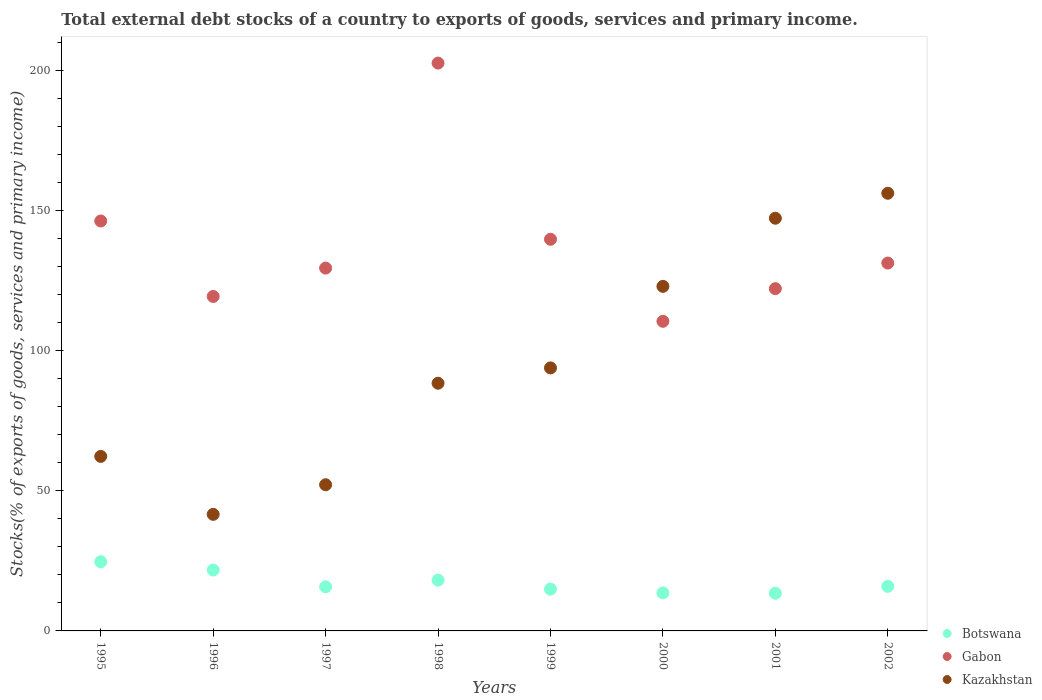How many different coloured dotlines are there?
Your response must be concise. 3. What is the total debt stocks in Kazakhstan in 2000?
Your answer should be very brief. 123. Across all years, what is the maximum total debt stocks in Gabon?
Keep it short and to the point. 202.7. Across all years, what is the minimum total debt stocks in Gabon?
Your response must be concise. 110.52. In which year was the total debt stocks in Gabon maximum?
Your response must be concise. 1998. What is the total total debt stocks in Botswana in the graph?
Provide a succinct answer. 138.16. What is the difference between the total debt stocks in Gabon in 1996 and that in 1997?
Your response must be concise. -10.12. What is the difference between the total debt stocks in Botswana in 2002 and the total debt stocks in Kazakhstan in 1999?
Your answer should be compact. -77.96. What is the average total debt stocks in Botswana per year?
Give a very brief answer. 17.27. In the year 2002, what is the difference between the total debt stocks in Botswana and total debt stocks in Kazakhstan?
Ensure brevity in your answer.  -140.3. In how many years, is the total debt stocks in Kazakhstan greater than 40 %?
Offer a very short reply. 8. What is the ratio of the total debt stocks in Botswana in 1997 to that in 2000?
Provide a succinct answer. 1.16. Is the difference between the total debt stocks in Botswana in 1996 and 2001 greater than the difference between the total debt stocks in Kazakhstan in 1996 and 2001?
Provide a succinct answer. Yes. What is the difference between the highest and the second highest total debt stocks in Gabon?
Provide a short and direct response. 56.36. What is the difference between the highest and the lowest total debt stocks in Botswana?
Give a very brief answer. 11.25. In how many years, is the total debt stocks in Kazakhstan greater than the average total debt stocks in Kazakhstan taken over all years?
Make the answer very short. 3. Is the sum of the total debt stocks in Botswana in 1997 and 2001 greater than the maximum total debt stocks in Kazakhstan across all years?
Keep it short and to the point. No. Is the total debt stocks in Gabon strictly greater than the total debt stocks in Kazakhstan over the years?
Your response must be concise. No. How many dotlines are there?
Keep it short and to the point. 3. How many years are there in the graph?
Your answer should be very brief. 8. Are the values on the major ticks of Y-axis written in scientific E-notation?
Ensure brevity in your answer.  No. How many legend labels are there?
Your response must be concise. 3. How are the legend labels stacked?
Offer a very short reply. Vertical. What is the title of the graph?
Ensure brevity in your answer.  Total external debt stocks of a country to exports of goods, services and primary income. What is the label or title of the Y-axis?
Ensure brevity in your answer.  Stocks(% of exports of goods, services and primary income). What is the Stocks(% of exports of goods, services and primary income) of Botswana in 1995?
Provide a succinct answer. 24.7. What is the Stocks(% of exports of goods, services and primary income) of Gabon in 1995?
Ensure brevity in your answer.  146.34. What is the Stocks(% of exports of goods, services and primary income) in Kazakhstan in 1995?
Give a very brief answer. 62.3. What is the Stocks(% of exports of goods, services and primary income) in Botswana in 1996?
Provide a succinct answer. 21.74. What is the Stocks(% of exports of goods, services and primary income) of Gabon in 1996?
Provide a succinct answer. 119.4. What is the Stocks(% of exports of goods, services and primary income) of Kazakhstan in 1996?
Your answer should be very brief. 41.61. What is the Stocks(% of exports of goods, services and primary income) of Botswana in 1997?
Give a very brief answer. 15.74. What is the Stocks(% of exports of goods, services and primary income) in Gabon in 1997?
Provide a succinct answer. 129.52. What is the Stocks(% of exports of goods, services and primary income) of Kazakhstan in 1997?
Your response must be concise. 52.18. What is the Stocks(% of exports of goods, services and primary income) in Botswana in 1998?
Provide a short and direct response. 18.11. What is the Stocks(% of exports of goods, services and primary income) of Gabon in 1998?
Offer a very short reply. 202.7. What is the Stocks(% of exports of goods, services and primary income) in Kazakhstan in 1998?
Make the answer very short. 88.42. What is the Stocks(% of exports of goods, services and primary income) in Botswana in 1999?
Keep it short and to the point. 14.92. What is the Stocks(% of exports of goods, services and primary income) in Gabon in 1999?
Provide a succinct answer. 139.81. What is the Stocks(% of exports of goods, services and primary income) in Kazakhstan in 1999?
Your answer should be very brief. 93.89. What is the Stocks(% of exports of goods, services and primary income) of Botswana in 2000?
Your response must be concise. 13.57. What is the Stocks(% of exports of goods, services and primary income) in Gabon in 2000?
Make the answer very short. 110.52. What is the Stocks(% of exports of goods, services and primary income) of Kazakhstan in 2000?
Your response must be concise. 123. What is the Stocks(% of exports of goods, services and primary income) of Botswana in 2001?
Your response must be concise. 13.45. What is the Stocks(% of exports of goods, services and primary income) of Gabon in 2001?
Keep it short and to the point. 122.18. What is the Stocks(% of exports of goods, services and primary income) of Kazakhstan in 2001?
Your answer should be very brief. 147.32. What is the Stocks(% of exports of goods, services and primary income) in Botswana in 2002?
Your answer should be very brief. 15.93. What is the Stocks(% of exports of goods, services and primary income) in Gabon in 2002?
Provide a short and direct response. 131.31. What is the Stocks(% of exports of goods, services and primary income) in Kazakhstan in 2002?
Keep it short and to the point. 156.23. Across all years, what is the maximum Stocks(% of exports of goods, services and primary income) of Botswana?
Provide a succinct answer. 24.7. Across all years, what is the maximum Stocks(% of exports of goods, services and primary income) in Gabon?
Make the answer very short. 202.7. Across all years, what is the maximum Stocks(% of exports of goods, services and primary income) in Kazakhstan?
Your answer should be compact. 156.23. Across all years, what is the minimum Stocks(% of exports of goods, services and primary income) in Botswana?
Keep it short and to the point. 13.45. Across all years, what is the minimum Stocks(% of exports of goods, services and primary income) of Gabon?
Ensure brevity in your answer.  110.52. Across all years, what is the minimum Stocks(% of exports of goods, services and primary income) in Kazakhstan?
Your answer should be very brief. 41.61. What is the total Stocks(% of exports of goods, services and primary income) of Botswana in the graph?
Provide a short and direct response. 138.16. What is the total Stocks(% of exports of goods, services and primary income) in Gabon in the graph?
Provide a succinct answer. 1101.78. What is the total Stocks(% of exports of goods, services and primary income) of Kazakhstan in the graph?
Make the answer very short. 764.96. What is the difference between the Stocks(% of exports of goods, services and primary income) in Botswana in 1995 and that in 1996?
Offer a terse response. 2.96. What is the difference between the Stocks(% of exports of goods, services and primary income) in Gabon in 1995 and that in 1996?
Give a very brief answer. 26.94. What is the difference between the Stocks(% of exports of goods, services and primary income) in Kazakhstan in 1995 and that in 1996?
Keep it short and to the point. 20.69. What is the difference between the Stocks(% of exports of goods, services and primary income) of Botswana in 1995 and that in 1997?
Your answer should be very brief. 8.96. What is the difference between the Stocks(% of exports of goods, services and primary income) of Gabon in 1995 and that in 1997?
Provide a short and direct response. 16.82. What is the difference between the Stocks(% of exports of goods, services and primary income) in Kazakhstan in 1995 and that in 1997?
Your response must be concise. 10.12. What is the difference between the Stocks(% of exports of goods, services and primary income) in Botswana in 1995 and that in 1998?
Make the answer very short. 6.59. What is the difference between the Stocks(% of exports of goods, services and primary income) of Gabon in 1995 and that in 1998?
Provide a short and direct response. -56.36. What is the difference between the Stocks(% of exports of goods, services and primary income) in Kazakhstan in 1995 and that in 1998?
Your answer should be compact. -26.12. What is the difference between the Stocks(% of exports of goods, services and primary income) of Botswana in 1995 and that in 1999?
Your answer should be compact. 9.78. What is the difference between the Stocks(% of exports of goods, services and primary income) in Gabon in 1995 and that in 1999?
Provide a short and direct response. 6.53. What is the difference between the Stocks(% of exports of goods, services and primary income) of Kazakhstan in 1995 and that in 1999?
Offer a terse response. -31.59. What is the difference between the Stocks(% of exports of goods, services and primary income) of Botswana in 1995 and that in 2000?
Your answer should be compact. 11.13. What is the difference between the Stocks(% of exports of goods, services and primary income) of Gabon in 1995 and that in 2000?
Keep it short and to the point. 35.81. What is the difference between the Stocks(% of exports of goods, services and primary income) in Kazakhstan in 1995 and that in 2000?
Your answer should be very brief. -60.7. What is the difference between the Stocks(% of exports of goods, services and primary income) of Botswana in 1995 and that in 2001?
Provide a short and direct response. 11.25. What is the difference between the Stocks(% of exports of goods, services and primary income) in Gabon in 1995 and that in 2001?
Give a very brief answer. 24.16. What is the difference between the Stocks(% of exports of goods, services and primary income) of Kazakhstan in 1995 and that in 2001?
Offer a very short reply. -85.02. What is the difference between the Stocks(% of exports of goods, services and primary income) of Botswana in 1995 and that in 2002?
Provide a short and direct response. 8.77. What is the difference between the Stocks(% of exports of goods, services and primary income) in Gabon in 1995 and that in 2002?
Provide a succinct answer. 15.02. What is the difference between the Stocks(% of exports of goods, services and primary income) of Kazakhstan in 1995 and that in 2002?
Keep it short and to the point. -93.93. What is the difference between the Stocks(% of exports of goods, services and primary income) in Botswana in 1996 and that in 1997?
Provide a succinct answer. 6. What is the difference between the Stocks(% of exports of goods, services and primary income) in Gabon in 1996 and that in 1997?
Provide a succinct answer. -10.12. What is the difference between the Stocks(% of exports of goods, services and primary income) in Kazakhstan in 1996 and that in 1997?
Your response must be concise. -10.57. What is the difference between the Stocks(% of exports of goods, services and primary income) in Botswana in 1996 and that in 1998?
Give a very brief answer. 3.63. What is the difference between the Stocks(% of exports of goods, services and primary income) of Gabon in 1996 and that in 1998?
Your answer should be very brief. -83.3. What is the difference between the Stocks(% of exports of goods, services and primary income) of Kazakhstan in 1996 and that in 1998?
Make the answer very short. -46.81. What is the difference between the Stocks(% of exports of goods, services and primary income) of Botswana in 1996 and that in 1999?
Offer a terse response. 6.82. What is the difference between the Stocks(% of exports of goods, services and primary income) of Gabon in 1996 and that in 1999?
Your answer should be compact. -20.41. What is the difference between the Stocks(% of exports of goods, services and primary income) of Kazakhstan in 1996 and that in 1999?
Your response must be concise. -52.28. What is the difference between the Stocks(% of exports of goods, services and primary income) in Botswana in 1996 and that in 2000?
Ensure brevity in your answer.  8.17. What is the difference between the Stocks(% of exports of goods, services and primary income) of Gabon in 1996 and that in 2000?
Offer a terse response. 8.88. What is the difference between the Stocks(% of exports of goods, services and primary income) in Kazakhstan in 1996 and that in 2000?
Give a very brief answer. -81.39. What is the difference between the Stocks(% of exports of goods, services and primary income) of Botswana in 1996 and that in 2001?
Give a very brief answer. 8.29. What is the difference between the Stocks(% of exports of goods, services and primary income) in Gabon in 1996 and that in 2001?
Give a very brief answer. -2.78. What is the difference between the Stocks(% of exports of goods, services and primary income) in Kazakhstan in 1996 and that in 2001?
Give a very brief answer. -105.71. What is the difference between the Stocks(% of exports of goods, services and primary income) in Botswana in 1996 and that in 2002?
Provide a succinct answer. 5.81. What is the difference between the Stocks(% of exports of goods, services and primary income) of Gabon in 1996 and that in 2002?
Ensure brevity in your answer.  -11.92. What is the difference between the Stocks(% of exports of goods, services and primary income) in Kazakhstan in 1996 and that in 2002?
Provide a succinct answer. -114.62. What is the difference between the Stocks(% of exports of goods, services and primary income) of Botswana in 1997 and that in 1998?
Your answer should be compact. -2.38. What is the difference between the Stocks(% of exports of goods, services and primary income) in Gabon in 1997 and that in 1998?
Provide a succinct answer. -73.18. What is the difference between the Stocks(% of exports of goods, services and primary income) of Kazakhstan in 1997 and that in 1998?
Your response must be concise. -36.24. What is the difference between the Stocks(% of exports of goods, services and primary income) in Botswana in 1997 and that in 1999?
Provide a succinct answer. 0.82. What is the difference between the Stocks(% of exports of goods, services and primary income) of Gabon in 1997 and that in 1999?
Make the answer very short. -10.29. What is the difference between the Stocks(% of exports of goods, services and primary income) in Kazakhstan in 1997 and that in 1999?
Give a very brief answer. -41.71. What is the difference between the Stocks(% of exports of goods, services and primary income) in Botswana in 1997 and that in 2000?
Give a very brief answer. 2.17. What is the difference between the Stocks(% of exports of goods, services and primary income) in Gabon in 1997 and that in 2000?
Your response must be concise. 19. What is the difference between the Stocks(% of exports of goods, services and primary income) in Kazakhstan in 1997 and that in 2000?
Your answer should be compact. -70.82. What is the difference between the Stocks(% of exports of goods, services and primary income) of Botswana in 1997 and that in 2001?
Provide a succinct answer. 2.29. What is the difference between the Stocks(% of exports of goods, services and primary income) in Gabon in 1997 and that in 2001?
Provide a succinct answer. 7.34. What is the difference between the Stocks(% of exports of goods, services and primary income) in Kazakhstan in 1997 and that in 2001?
Provide a succinct answer. -95.14. What is the difference between the Stocks(% of exports of goods, services and primary income) in Botswana in 1997 and that in 2002?
Offer a terse response. -0.19. What is the difference between the Stocks(% of exports of goods, services and primary income) in Gabon in 1997 and that in 2002?
Your answer should be compact. -1.79. What is the difference between the Stocks(% of exports of goods, services and primary income) of Kazakhstan in 1997 and that in 2002?
Give a very brief answer. -104.05. What is the difference between the Stocks(% of exports of goods, services and primary income) of Botswana in 1998 and that in 1999?
Your answer should be very brief. 3.19. What is the difference between the Stocks(% of exports of goods, services and primary income) in Gabon in 1998 and that in 1999?
Provide a short and direct response. 62.89. What is the difference between the Stocks(% of exports of goods, services and primary income) of Kazakhstan in 1998 and that in 1999?
Your answer should be compact. -5.47. What is the difference between the Stocks(% of exports of goods, services and primary income) in Botswana in 1998 and that in 2000?
Keep it short and to the point. 4.54. What is the difference between the Stocks(% of exports of goods, services and primary income) of Gabon in 1998 and that in 2000?
Keep it short and to the point. 92.18. What is the difference between the Stocks(% of exports of goods, services and primary income) in Kazakhstan in 1998 and that in 2000?
Ensure brevity in your answer.  -34.58. What is the difference between the Stocks(% of exports of goods, services and primary income) of Botswana in 1998 and that in 2001?
Make the answer very short. 4.66. What is the difference between the Stocks(% of exports of goods, services and primary income) in Gabon in 1998 and that in 2001?
Provide a short and direct response. 80.53. What is the difference between the Stocks(% of exports of goods, services and primary income) of Kazakhstan in 1998 and that in 2001?
Ensure brevity in your answer.  -58.9. What is the difference between the Stocks(% of exports of goods, services and primary income) of Botswana in 1998 and that in 2002?
Provide a succinct answer. 2.18. What is the difference between the Stocks(% of exports of goods, services and primary income) of Gabon in 1998 and that in 2002?
Make the answer very short. 71.39. What is the difference between the Stocks(% of exports of goods, services and primary income) in Kazakhstan in 1998 and that in 2002?
Make the answer very short. -67.81. What is the difference between the Stocks(% of exports of goods, services and primary income) of Botswana in 1999 and that in 2000?
Offer a terse response. 1.35. What is the difference between the Stocks(% of exports of goods, services and primary income) of Gabon in 1999 and that in 2000?
Keep it short and to the point. 29.28. What is the difference between the Stocks(% of exports of goods, services and primary income) of Kazakhstan in 1999 and that in 2000?
Keep it short and to the point. -29.11. What is the difference between the Stocks(% of exports of goods, services and primary income) of Botswana in 1999 and that in 2001?
Provide a succinct answer. 1.47. What is the difference between the Stocks(% of exports of goods, services and primary income) in Gabon in 1999 and that in 2001?
Provide a short and direct response. 17.63. What is the difference between the Stocks(% of exports of goods, services and primary income) in Kazakhstan in 1999 and that in 2001?
Ensure brevity in your answer.  -53.43. What is the difference between the Stocks(% of exports of goods, services and primary income) in Botswana in 1999 and that in 2002?
Offer a terse response. -1.01. What is the difference between the Stocks(% of exports of goods, services and primary income) in Gabon in 1999 and that in 2002?
Your answer should be very brief. 8.49. What is the difference between the Stocks(% of exports of goods, services and primary income) of Kazakhstan in 1999 and that in 2002?
Offer a terse response. -62.34. What is the difference between the Stocks(% of exports of goods, services and primary income) of Botswana in 2000 and that in 2001?
Ensure brevity in your answer.  0.12. What is the difference between the Stocks(% of exports of goods, services and primary income) in Gabon in 2000 and that in 2001?
Provide a succinct answer. -11.65. What is the difference between the Stocks(% of exports of goods, services and primary income) of Kazakhstan in 2000 and that in 2001?
Offer a terse response. -24.32. What is the difference between the Stocks(% of exports of goods, services and primary income) in Botswana in 2000 and that in 2002?
Ensure brevity in your answer.  -2.36. What is the difference between the Stocks(% of exports of goods, services and primary income) in Gabon in 2000 and that in 2002?
Your response must be concise. -20.79. What is the difference between the Stocks(% of exports of goods, services and primary income) in Kazakhstan in 2000 and that in 2002?
Offer a very short reply. -33.23. What is the difference between the Stocks(% of exports of goods, services and primary income) of Botswana in 2001 and that in 2002?
Make the answer very short. -2.48. What is the difference between the Stocks(% of exports of goods, services and primary income) of Gabon in 2001 and that in 2002?
Ensure brevity in your answer.  -9.14. What is the difference between the Stocks(% of exports of goods, services and primary income) of Kazakhstan in 2001 and that in 2002?
Make the answer very short. -8.91. What is the difference between the Stocks(% of exports of goods, services and primary income) in Botswana in 1995 and the Stocks(% of exports of goods, services and primary income) in Gabon in 1996?
Offer a very short reply. -94.7. What is the difference between the Stocks(% of exports of goods, services and primary income) in Botswana in 1995 and the Stocks(% of exports of goods, services and primary income) in Kazakhstan in 1996?
Offer a terse response. -16.91. What is the difference between the Stocks(% of exports of goods, services and primary income) in Gabon in 1995 and the Stocks(% of exports of goods, services and primary income) in Kazakhstan in 1996?
Your answer should be compact. 104.73. What is the difference between the Stocks(% of exports of goods, services and primary income) in Botswana in 1995 and the Stocks(% of exports of goods, services and primary income) in Gabon in 1997?
Ensure brevity in your answer.  -104.82. What is the difference between the Stocks(% of exports of goods, services and primary income) of Botswana in 1995 and the Stocks(% of exports of goods, services and primary income) of Kazakhstan in 1997?
Provide a short and direct response. -27.48. What is the difference between the Stocks(% of exports of goods, services and primary income) of Gabon in 1995 and the Stocks(% of exports of goods, services and primary income) of Kazakhstan in 1997?
Provide a short and direct response. 94.16. What is the difference between the Stocks(% of exports of goods, services and primary income) of Botswana in 1995 and the Stocks(% of exports of goods, services and primary income) of Gabon in 1998?
Provide a succinct answer. -178. What is the difference between the Stocks(% of exports of goods, services and primary income) of Botswana in 1995 and the Stocks(% of exports of goods, services and primary income) of Kazakhstan in 1998?
Your response must be concise. -63.72. What is the difference between the Stocks(% of exports of goods, services and primary income) of Gabon in 1995 and the Stocks(% of exports of goods, services and primary income) of Kazakhstan in 1998?
Ensure brevity in your answer.  57.92. What is the difference between the Stocks(% of exports of goods, services and primary income) of Botswana in 1995 and the Stocks(% of exports of goods, services and primary income) of Gabon in 1999?
Provide a succinct answer. -115.11. What is the difference between the Stocks(% of exports of goods, services and primary income) of Botswana in 1995 and the Stocks(% of exports of goods, services and primary income) of Kazakhstan in 1999?
Your response must be concise. -69.19. What is the difference between the Stocks(% of exports of goods, services and primary income) of Gabon in 1995 and the Stocks(% of exports of goods, services and primary income) of Kazakhstan in 1999?
Provide a short and direct response. 52.45. What is the difference between the Stocks(% of exports of goods, services and primary income) of Botswana in 1995 and the Stocks(% of exports of goods, services and primary income) of Gabon in 2000?
Give a very brief answer. -85.83. What is the difference between the Stocks(% of exports of goods, services and primary income) of Botswana in 1995 and the Stocks(% of exports of goods, services and primary income) of Kazakhstan in 2000?
Ensure brevity in your answer.  -98.3. What is the difference between the Stocks(% of exports of goods, services and primary income) of Gabon in 1995 and the Stocks(% of exports of goods, services and primary income) of Kazakhstan in 2000?
Give a very brief answer. 23.34. What is the difference between the Stocks(% of exports of goods, services and primary income) of Botswana in 1995 and the Stocks(% of exports of goods, services and primary income) of Gabon in 2001?
Make the answer very short. -97.48. What is the difference between the Stocks(% of exports of goods, services and primary income) of Botswana in 1995 and the Stocks(% of exports of goods, services and primary income) of Kazakhstan in 2001?
Provide a short and direct response. -122.62. What is the difference between the Stocks(% of exports of goods, services and primary income) in Gabon in 1995 and the Stocks(% of exports of goods, services and primary income) in Kazakhstan in 2001?
Your answer should be very brief. -0.98. What is the difference between the Stocks(% of exports of goods, services and primary income) in Botswana in 1995 and the Stocks(% of exports of goods, services and primary income) in Gabon in 2002?
Offer a terse response. -106.62. What is the difference between the Stocks(% of exports of goods, services and primary income) in Botswana in 1995 and the Stocks(% of exports of goods, services and primary income) in Kazakhstan in 2002?
Ensure brevity in your answer.  -131.54. What is the difference between the Stocks(% of exports of goods, services and primary income) of Gabon in 1995 and the Stocks(% of exports of goods, services and primary income) of Kazakhstan in 2002?
Offer a terse response. -9.9. What is the difference between the Stocks(% of exports of goods, services and primary income) in Botswana in 1996 and the Stocks(% of exports of goods, services and primary income) in Gabon in 1997?
Your answer should be compact. -107.78. What is the difference between the Stocks(% of exports of goods, services and primary income) of Botswana in 1996 and the Stocks(% of exports of goods, services and primary income) of Kazakhstan in 1997?
Provide a succinct answer. -30.44. What is the difference between the Stocks(% of exports of goods, services and primary income) in Gabon in 1996 and the Stocks(% of exports of goods, services and primary income) in Kazakhstan in 1997?
Ensure brevity in your answer.  67.22. What is the difference between the Stocks(% of exports of goods, services and primary income) of Botswana in 1996 and the Stocks(% of exports of goods, services and primary income) of Gabon in 1998?
Your response must be concise. -180.96. What is the difference between the Stocks(% of exports of goods, services and primary income) of Botswana in 1996 and the Stocks(% of exports of goods, services and primary income) of Kazakhstan in 1998?
Your answer should be very brief. -66.68. What is the difference between the Stocks(% of exports of goods, services and primary income) of Gabon in 1996 and the Stocks(% of exports of goods, services and primary income) of Kazakhstan in 1998?
Your answer should be compact. 30.98. What is the difference between the Stocks(% of exports of goods, services and primary income) in Botswana in 1996 and the Stocks(% of exports of goods, services and primary income) in Gabon in 1999?
Ensure brevity in your answer.  -118.07. What is the difference between the Stocks(% of exports of goods, services and primary income) of Botswana in 1996 and the Stocks(% of exports of goods, services and primary income) of Kazakhstan in 1999?
Your answer should be very brief. -72.15. What is the difference between the Stocks(% of exports of goods, services and primary income) of Gabon in 1996 and the Stocks(% of exports of goods, services and primary income) of Kazakhstan in 1999?
Your response must be concise. 25.51. What is the difference between the Stocks(% of exports of goods, services and primary income) of Botswana in 1996 and the Stocks(% of exports of goods, services and primary income) of Gabon in 2000?
Offer a very short reply. -88.79. What is the difference between the Stocks(% of exports of goods, services and primary income) in Botswana in 1996 and the Stocks(% of exports of goods, services and primary income) in Kazakhstan in 2000?
Your answer should be compact. -101.26. What is the difference between the Stocks(% of exports of goods, services and primary income) of Gabon in 1996 and the Stocks(% of exports of goods, services and primary income) of Kazakhstan in 2000?
Offer a terse response. -3.6. What is the difference between the Stocks(% of exports of goods, services and primary income) of Botswana in 1996 and the Stocks(% of exports of goods, services and primary income) of Gabon in 2001?
Give a very brief answer. -100.44. What is the difference between the Stocks(% of exports of goods, services and primary income) of Botswana in 1996 and the Stocks(% of exports of goods, services and primary income) of Kazakhstan in 2001?
Provide a succinct answer. -125.58. What is the difference between the Stocks(% of exports of goods, services and primary income) of Gabon in 1996 and the Stocks(% of exports of goods, services and primary income) of Kazakhstan in 2001?
Offer a terse response. -27.92. What is the difference between the Stocks(% of exports of goods, services and primary income) in Botswana in 1996 and the Stocks(% of exports of goods, services and primary income) in Gabon in 2002?
Ensure brevity in your answer.  -109.58. What is the difference between the Stocks(% of exports of goods, services and primary income) in Botswana in 1996 and the Stocks(% of exports of goods, services and primary income) in Kazakhstan in 2002?
Ensure brevity in your answer.  -134.5. What is the difference between the Stocks(% of exports of goods, services and primary income) in Gabon in 1996 and the Stocks(% of exports of goods, services and primary income) in Kazakhstan in 2002?
Provide a short and direct response. -36.83. What is the difference between the Stocks(% of exports of goods, services and primary income) of Botswana in 1997 and the Stocks(% of exports of goods, services and primary income) of Gabon in 1998?
Your answer should be compact. -186.96. What is the difference between the Stocks(% of exports of goods, services and primary income) of Botswana in 1997 and the Stocks(% of exports of goods, services and primary income) of Kazakhstan in 1998?
Your response must be concise. -72.68. What is the difference between the Stocks(% of exports of goods, services and primary income) of Gabon in 1997 and the Stocks(% of exports of goods, services and primary income) of Kazakhstan in 1998?
Offer a terse response. 41.1. What is the difference between the Stocks(% of exports of goods, services and primary income) of Botswana in 1997 and the Stocks(% of exports of goods, services and primary income) of Gabon in 1999?
Your answer should be very brief. -124.07. What is the difference between the Stocks(% of exports of goods, services and primary income) in Botswana in 1997 and the Stocks(% of exports of goods, services and primary income) in Kazakhstan in 1999?
Ensure brevity in your answer.  -78.15. What is the difference between the Stocks(% of exports of goods, services and primary income) in Gabon in 1997 and the Stocks(% of exports of goods, services and primary income) in Kazakhstan in 1999?
Your answer should be very brief. 35.63. What is the difference between the Stocks(% of exports of goods, services and primary income) of Botswana in 1997 and the Stocks(% of exports of goods, services and primary income) of Gabon in 2000?
Give a very brief answer. -94.79. What is the difference between the Stocks(% of exports of goods, services and primary income) of Botswana in 1997 and the Stocks(% of exports of goods, services and primary income) of Kazakhstan in 2000?
Make the answer very short. -107.26. What is the difference between the Stocks(% of exports of goods, services and primary income) in Gabon in 1997 and the Stocks(% of exports of goods, services and primary income) in Kazakhstan in 2000?
Offer a terse response. 6.52. What is the difference between the Stocks(% of exports of goods, services and primary income) in Botswana in 1997 and the Stocks(% of exports of goods, services and primary income) in Gabon in 2001?
Ensure brevity in your answer.  -106.44. What is the difference between the Stocks(% of exports of goods, services and primary income) in Botswana in 1997 and the Stocks(% of exports of goods, services and primary income) in Kazakhstan in 2001?
Offer a very short reply. -131.58. What is the difference between the Stocks(% of exports of goods, services and primary income) in Gabon in 1997 and the Stocks(% of exports of goods, services and primary income) in Kazakhstan in 2001?
Provide a short and direct response. -17.8. What is the difference between the Stocks(% of exports of goods, services and primary income) of Botswana in 1997 and the Stocks(% of exports of goods, services and primary income) of Gabon in 2002?
Provide a short and direct response. -115.58. What is the difference between the Stocks(% of exports of goods, services and primary income) in Botswana in 1997 and the Stocks(% of exports of goods, services and primary income) in Kazakhstan in 2002?
Give a very brief answer. -140.5. What is the difference between the Stocks(% of exports of goods, services and primary income) of Gabon in 1997 and the Stocks(% of exports of goods, services and primary income) of Kazakhstan in 2002?
Offer a terse response. -26.71. What is the difference between the Stocks(% of exports of goods, services and primary income) of Botswana in 1998 and the Stocks(% of exports of goods, services and primary income) of Gabon in 1999?
Ensure brevity in your answer.  -121.7. What is the difference between the Stocks(% of exports of goods, services and primary income) in Botswana in 1998 and the Stocks(% of exports of goods, services and primary income) in Kazakhstan in 1999?
Your answer should be very brief. -75.78. What is the difference between the Stocks(% of exports of goods, services and primary income) of Gabon in 1998 and the Stocks(% of exports of goods, services and primary income) of Kazakhstan in 1999?
Make the answer very short. 108.81. What is the difference between the Stocks(% of exports of goods, services and primary income) in Botswana in 1998 and the Stocks(% of exports of goods, services and primary income) in Gabon in 2000?
Ensure brevity in your answer.  -92.41. What is the difference between the Stocks(% of exports of goods, services and primary income) of Botswana in 1998 and the Stocks(% of exports of goods, services and primary income) of Kazakhstan in 2000?
Your response must be concise. -104.89. What is the difference between the Stocks(% of exports of goods, services and primary income) of Gabon in 1998 and the Stocks(% of exports of goods, services and primary income) of Kazakhstan in 2000?
Keep it short and to the point. 79.7. What is the difference between the Stocks(% of exports of goods, services and primary income) of Botswana in 1998 and the Stocks(% of exports of goods, services and primary income) of Gabon in 2001?
Ensure brevity in your answer.  -104.06. What is the difference between the Stocks(% of exports of goods, services and primary income) in Botswana in 1998 and the Stocks(% of exports of goods, services and primary income) in Kazakhstan in 2001?
Keep it short and to the point. -129.21. What is the difference between the Stocks(% of exports of goods, services and primary income) of Gabon in 1998 and the Stocks(% of exports of goods, services and primary income) of Kazakhstan in 2001?
Offer a terse response. 55.38. What is the difference between the Stocks(% of exports of goods, services and primary income) of Botswana in 1998 and the Stocks(% of exports of goods, services and primary income) of Gabon in 2002?
Your response must be concise. -113.2. What is the difference between the Stocks(% of exports of goods, services and primary income) in Botswana in 1998 and the Stocks(% of exports of goods, services and primary income) in Kazakhstan in 2002?
Provide a succinct answer. -138.12. What is the difference between the Stocks(% of exports of goods, services and primary income) in Gabon in 1998 and the Stocks(% of exports of goods, services and primary income) in Kazakhstan in 2002?
Give a very brief answer. 46.47. What is the difference between the Stocks(% of exports of goods, services and primary income) in Botswana in 1999 and the Stocks(% of exports of goods, services and primary income) in Gabon in 2000?
Your response must be concise. -95.6. What is the difference between the Stocks(% of exports of goods, services and primary income) in Botswana in 1999 and the Stocks(% of exports of goods, services and primary income) in Kazakhstan in 2000?
Ensure brevity in your answer.  -108.08. What is the difference between the Stocks(% of exports of goods, services and primary income) in Gabon in 1999 and the Stocks(% of exports of goods, services and primary income) in Kazakhstan in 2000?
Offer a very short reply. 16.81. What is the difference between the Stocks(% of exports of goods, services and primary income) of Botswana in 1999 and the Stocks(% of exports of goods, services and primary income) of Gabon in 2001?
Offer a terse response. -107.25. What is the difference between the Stocks(% of exports of goods, services and primary income) of Botswana in 1999 and the Stocks(% of exports of goods, services and primary income) of Kazakhstan in 2001?
Your answer should be very brief. -132.4. What is the difference between the Stocks(% of exports of goods, services and primary income) of Gabon in 1999 and the Stocks(% of exports of goods, services and primary income) of Kazakhstan in 2001?
Your response must be concise. -7.51. What is the difference between the Stocks(% of exports of goods, services and primary income) in Botswana in 1999 and the Stocks(% of exports of goods, services and primary income) in Gabon in 2002?
Make the answer very short. -116.39. What is the difference between the Stocks(% of exports of goods, services and primary income) of Botswana in 1999 and the Stocks(% of exports of goods, services and primary income) of Kazakhstan in 2002?
Your response must be concise. -141.31. What is the difference between the Stocks(% of exports of goods, services and primary income) of Gabon in 1999 and the Stocks(% of exports of goods, services and primary income) of Kazakhstan in 2002?
Offer a terse response. -16.43. What is the difference between the Stocks(% of exports of goods, services and primary income) in Botswana in 2000 and the Stocks(% of exports of goods, services and primary income) in Gabon in 2001?
Offer a terse response. -108.61. What is the difference between the Stocks(% of exports of goods, services and primary income) of Botswana in 2000 and the Stocks(% of exports of goods, services and primary income) of Kazakhstan in 2001?
Provide a succinct answer. -133.75. What is the difference between the Stocks(% of exports of goods, services and primary income) of Gabon in 2000 and the Stocks(% of exports of goods, services and primary income) of Kazakhstan in 2001?
Give a very brief answer. -36.8. What is the difference between the Stocks(% of exports of goods, services and primary income) of Botswana in 2000 and the Stocks(% of exports of goods, services and primary income) of Gabon in 2002?
Make the answer very short. -117.74. What is the difference between the Stocks(% of exports of goods, services and primary income) of Botswana in 2000 and the Stocks(% of exports of goods, services and primary income) of Kazakhstan in 2002?
Your answer should be very brief. -142.66. What is the difference between the Stocks(% of exports of goods, services and primary income) of Gabon in 2000 and the Stocks(% of exports of goods, services and primary income) of Kazakhstan in 2002?
Your answer should be compact. -45.71. What is the difference between the Stocks(% of exports of goods, services and primary income) in Botswana in 2001 and the Stocks(% of exports of goods, services and primary income) in Gabon in 2002?
Provide a succinct answer. -117.86. What is the difference between the Stocks(% of exports of goods, services and primary income) of Botswana in 2001 and the Stocks(% of exports of goods, services and primary income) of Kazakhstan in 2002?
Provide a short and direct response. -142.78. What is the difference between the Stocks(% of exports of goods, services and primary income) of Gabon in 2001 and the Stocks(% of exports of goods, services and primary income) of Kazakhstan in 2002?
Offer a very short reply. -34.06. What is the average Stocks(% of exports of goods, services and primary income) in Botswana per year?
Keep it short and to the point. 17.27. What is the average Stocks(% of exports of goods, services and primary income) of Gabon per year?
Provide a succinct answer. 137.72. What is the average Stocks(% of exports of goods, services and primary income) of Kazakhstan per year?
Make the answer very short. 95.62. In the year 1995, what is the difference between the Stocks(% of exports of goods, services and primary income) in Botswana and Stocks(% of exports of goods, services and primary income) in Gabon?
Keep it short and to the point. -121.64. In the year 1995, what is the difference between the Stocks(% of exports of goods, services and primary income) of Botswana and Stocks(% of exports of goods, services and primary income) of Kazakhstan?
Offer a terse response. -37.6. In the year 1995, what is the difference between the Stocks(% of exports of goods, services and primary income) in Gabon and Stocks(% of exports of goods, services and primary income) in Kazakhstan?
Provide a succinct answer. 84.04. In the year 1996, what is the difference between the Stocks(% of exports of goods, services and primary income) of Botswana and Stocks(% of exports of goods, services and primary income) of Gabon?
Provide a succinct answer. -97.66. In the year 1996, what is the difference between the Stocks(% of exports of goods, services and primary income) of Botswana and Stocks(% of exports of goods, services and primary income) of Kazakhstan?
Provide a succinct answer. -19.87. In the year 1996, what is the difference between the Stocks(% of exports of goods, services and primary income) in Gabon and Stocks(% of exports of goods, services and primary income) in Kazakhstan?
Your answer should be compact. 77.79. In the year 1997, what is the difference between the Stocks(% of exports of goods, services and primary income) of Botswana and Stocks(% of exports of goods, services and primary income) of Gabon?
Give a very brief answer. -113.78. In the year 1997, what is the difference between the Stocks(% of exports of goods, services and primary income) in Botswana and Stocks(% of exports of goods, services and primary income) in Kazakhstan?
Keep it short and to the point. -36.44. In the year 1997, what is the difference between the Stocks(% of exports of goods, services and primary income) in Gabon and Stocks(% of exports of goods, services and primary income) in Kazakhstan?
Offer a very short reply. 77.34. In the year 1998, what is the difference between the Stocks(% of exports of goods, services and primary income) in Botswana and Stocks(% of exports of goods, services and primary income) in Gabon?
Make the answer very short. -184.59. In the year 1998, what is the difference between the Stocks(% of exports of goods, services and primary income) in Botswana and Stocks(% of exports of goods, services and primary income) in Kazakhstan?
Ensure brevity in your answer.  -70.31. In the year 1998, what is the difference between the Stocks(% of exports of goods, services and primary income) of Gabon and Stocks(% of exports of goods, services and primary income) of Kazakhstan?
Your response must be concise. 114.28. In the year 1999, what is the difference between the Stocks(% of exports of goods, services and primary income) in Botswana and Stocks(% of exports of goods, services and primary income) in Gabon?
Offer a very short reply. -124.89. In the year 1999, what is the difference between the Stocks(% of exports of goods, services and primary income) in Botswana and Stocks(% of exports of goods, services and primary income) in Kazakhstan?
Provide a short and direct response. -78.97. In the year 1999, what is the difference between the Stocks(% of exports of goods, services and primary income) of Gabon and Stocks(% of exports of goods, services and primary income) of Kazakhstan?
Your response must be concise. 45.92. In the year 2000, what is the difference between the Stocks(% of exports of goods, services and primary income) of Botswana and Stocks(% of exports of goods, services and primary income) of Gabon?
Provide a succinct answer. -96.95. In the year 2000, what is the difference between the Stocks(% of exports of goods, services and primary income) of Botswana and Stocks(% of exports of goods, services and primary income) of Kazakhstan?
Provide a succinct answer. -109.43. In the year 2000, what is the difference between the Stocks(% of exports of goods, services and primary income) of Gabon and Stocks(% of exports of goods, services and primary income) of Kazakhstan?
Provide a short and direct response. -12.48. In the year 2001, what is the difference between the Stocks(% of exports of goods, services and primary income) of Botswana and Stocks(% of exports of goods, services and primary income) of Gabon?
Give a very brief answer. -108.73. In the year 2001, what is the difference between the Stocks(% of exports of goods, services and primary income) of Botswana and Stocks(% of exports of goods, services and primary income) of Kazakhstan?
Keep it short and to the point. -133.87. In the year 2001, what is the difference between the Stocks(% of exports of goods, services and primary income) in Gabon and Stocks(% of exports of goods, services and primary income) in Kazakhstan?
Offer a terse response. -25.14. In the year 2002, what is the difference between the Stocks(% of exports of goods, services and primary income) of Botswana and Stocks(% of exports of goods, services and primary income) of Gabon?
Provide a succinct answer. -115.39. In the year 2002, what is the difference between the Stocks(% of exports of goods, services and primary income) in Botswana and Stocks(% of exports of goods, services and primary income) in Kazakhstan?
Provide a short and direct response. -140.3. In the year 2002, what is the difference between the Stocks(% of exports of goods, services and primary income) of Gabon and Stocks(% of exports of goods, services and primary income) of Kazakhstan?
Ensure brevity in your answer.  -24.92. What is the ratio of the Stocks(% of exports of goods, services and primary income) of Botswana in 1995 to that in 1996?
Offer a terse response. 1.14. What is the ratio of the Stocks(% of exports of goods, services and primary income) of Gabon in 1995 to that in 1996?
Your answer should be compact. 1.23. What is the ratio of the Stocks(% of exports of goods, services and primary income) of Kazakhstan in 1995 to that in 1996?
Keep it short and to the point. 1.5. What is the ratio of the Stocks(% of exports of goods, services and primary income) of Botswana in 1995 to that in 1997?
Offer a terse response. 1.57. What is the ratio of the Stocks(% of exports of goods, services and primary income) in Gabon in 1995 to that in 1997?
Provide a short and direct response. 1.13. What is the ratio of the Stocks(% of exports of goods, services and primary income) of Kazakhstan in 1995 to that in 1997?
Your response must be concise. 1.19. What is the ratio of the Stocks(% of exports of goods, services and primary income) of Botswana in 1995 to that in 1998?
Keep it short and to the point. 1.36. What is the ratio of the Stocks(% of exports of goods, services and primary income) in Gabon in 1995 to that in 1998?
Offer a terse response. 0.72. What is the ratio of the Stocks(% of exports of goods, services and primary income) of Kazakhstan in 1995 to that in 1998?
Offer a terse response. 0.7. What is the ratio of the Stocks(% of exports of goods, services and primary income) in Botswana in 1995 to that in 1999?
Provide a succinct answer. 1.66. What is the ratio of the Stocks(% of exports of goods, services and primary income) in Gabon in 1995 to that in 1999?
Give a very brief answer. 1.05. What is the ratio of the Stocks(% of exports of goods, services and primary income) of Kazakhstan in 1995 to that in 1999?
Provide a succinct answer. 0.66. What is the ratio of the Stocks(% of exports of goods, services and primary income) of Botswana in 1995 to that in 2000?
Provide a succinct answer. 1.82. What is the ratio of the Stocks(% of exports of goods, services and primary income) of Gabon in 1995 to that in 2000?
Offer a very short reply. 1.32. What is the ratio of the Stocks(% of exports of goods, services and primary income) in Kazakhstan in 1995 to that in 2000?
Offer a very short reply. 0.51. What is the ratio of the Stocks(% of exports of goods, services and primary income) of Botswana in 1995 to that in 2001?
Keep it short and to the point. 1.84. What is the ratio of the Stocks(% of exports of goods, services and primary income) of Gabon in 1995 to that in 2001?
Keep it short and to the point. 1.2. What is the ratio of the Stocks(% of exports of goods, services and primary income) in Kazakhstan in 1995 to that in 2001?
Provide a short and direct response. 0.42. What is the ratio of the Stocks(% of exports of goods, services and primary income) of Botswana in 1995 to that in 2002?
Your answer should be compact. 1.55. What is the ratio of the Stocks(% of exports of goods, services and primary income) in Gabon in 1995 to that in 2002?
Ensure brevity in your answer.  1.11. What is the ratio of the Stocks(% of exports of goods, services and primary income) of Kazakhstan in 1995 to that in 2002?
Make the answer very short. 0.4. What is the ratio of the Stocks(% of exports of goods, services and primary income) in Botswana in 1996 to that in 1997?
Offer a terse response. 1.38. What is the ratio of the Stocks(% of exports of goods, services and primary income) of Gabon in 1996 to that in 1997?
Keep it short and to the point. 0.92. What is the ratio of the Stocks(% of exports of goods, services and primary income) of Kazakhstan in 1996 to that in 1997?
Keep it short and to the point. 0.8. What is the ratio of the Stocks(% of exports of goods, services and primary income) of Botswana in 1996 to that in 1998?
Provide a short and direct response. 1.2. What is the ratio of the Stocks(% of exports of goods, services and primary income) of Gabon in 1996 to that in 1998?
Your answer should be compact. 0.59. What is the ratio of the Stocks(% of exports of goods, services and primary income) in Kazakhstan in 1996 to that in 1998?
Provide a short and direct response. 0.47. What is the ratio of the Stocks(% of exports of goods, services and primary income) of Botswana in 1996 to that in 1999?
Your answer should be very brief. 1.46. What is the ratio of the Stocks(% of exports of goods, services and primary income) of Gabon in 1996 to that in 1999?
Provide a short and direct response. 0.85. What is the ratio of the Stocks(% of exports of goods, services and primary income) of Kazakhstan in 1996 to that in 1999?
Keep it short and to the point. 0.44. What is the ratio of the Stocks(% of exports of goods, services and primary income) in Botswana in 1996 to that in 2000?
Give a very brief answer. 1.6. What is the ratio of the Stocks(% of exports of goods, services and primary income) of Gabon in 1996 to that in 2000?
Your answer should be very brief. 1.08. What is the ratio of the Stocks(% of exports of goods, services and primary income) of Kazakhstan in 1996 to that in 2000?
Give a very brief answer. 0.34. What is the ratio of the Stocks(% of exports of goods, services and primary income) of Botswana in 1996 to that in 2001?
Your answer should be very brief. 1.62. What is the ratio of the Stocks(% of exports of goods, services and primary income) in Gabon in 1996 to that in 2001?
Keep it short and to the point. 0.98. What is the ratio of the Stocks(% of exports of goods, services and primary income) of Kazakhstan in 1996 to that in 2001?
Ensure brevity in your answer.  0.28. What is the ratio of the Stocks(% of exports of goods, services and primary income) of Botswana in 1996 to that in 2002?
Your answer should be compact. 1.36. What is the ratio of the Stocks(% of exports of goods, services and primary income) in Gabon in 1996 to that in 2002?
Provide a short and direct response. 0.91. What is the ratio of the Stocks(% of exports of goods, services and primary income) in Kazakhstan in 1996 to that in 2002?
Provide a succinct answer. 0.27. What is the ratio of the Stocks(% of exports of goods, services and primary income) of Botswana in 1997 to that in 1998?
Provide a succinct answer. 0.87. What is the ratio of the Stocks(% of exports of goods, services and primary income) of Gabon in 1997 to that in 1998?
Your answer should be very brief. 0.64. What is the ratio of the Stocks(% of exports of goods, services and primary income) of Kazakhstan in 1997 to that in 1998?
Your answer should be very brief. 0.59. What is the ratio of the Stocks(% of exports of goods, services and primary income) in Botswana in 1997 to that in 1999?
Your answer should be compact. 1.05. What is the ratio of the Stocks(% of exports of goods, services and primary income) in Gabon in 1997 to that in 1999?
Your answer should be very brief. 0.93. What is the ratio of the Stocks(% of exports of goods, services and primary income) in Kazakhstan in 1997 to that in 1999?
Offer a very short reply. 0.56. What is the ratio of the Stocks(% of exports of goods, services and primary income) of Botswana in 1997 to that in 2000?
Make the answer very short. 1.16. What is the ratio of the Stocks(% of exports of goods, services and primary income) of Gabon in 1997 to that in 2000?
Keep it short and to the point. 1.17. What is the ratio of the Stocks(% of exports of goods, services and primary income) of Kazakhstan in 1997 to that in 2000?
Provide a short and direct response. 0.42. What is the ratio of the Stocks(% of exports of goods, services and primary income) in Botswana in 1997 to that in 2001?
Offer a terse response. 1.17. What is the ratio of the Stocks(% of exports of goods, services and primary income) of Gabon in 1997 to that in 2001?
Keep it short and to the point. 1.06. What is the ratio of the Stocks(% of exports of goods, services and primary income) in Kazakhstan in 1997 to that in 2001?
Ensure brevity in your answer.  0.35. What is the ratio of the Stocks(% of exports of goods, services and primary income) in Botswana in 1997 to that in 2002?
Provide a short and direct response. 0.99. What is the ratio of the Stocks(% of exports of goods, services and primary income) in Gabon in 1997 to that in 2002?
Ensure brevity in your answer.  0.99. What is the ratio of the Stocks(% of exports of goods, services and primary income) in Kazakhstan in 1997 to that in 2002?
Keep it short and to the point. 0.33. What is the ratio of the Stocks(% of exports of goods, services and primary income) in Botswana in 1998 to that in 1999?
Ensure brevity in your answer.  1.21. What is the ratio of the Stocks(% of exports of goods, services and primary income) in Gabon in 1998 to that in 1999?
Provide a succinct answer. 1.45. What is the ratio of the Stocks(% of exports of goods, services and primary income) in Kazakhstan in 1998 to that in 1999?
Your answer should be very brief. 0.94. What is the ratio of the Stocks(% of exports of goods, services and primary income) in Botswana in 1998 to that in 2000?
Provide a succinct answer. 1.33. What is the ratio of the Stocks(% of exports of goods, services and primary income) of Gabon in 1998 to that in 2000?
Make the answer very short. 1.83. What is the ratio of the Stocks(% of exports of goods, services and primary income) in Kazakhstan in 1998 to that in 2000?
Offer a terse response. 0.72. What is the ratio of the Stocks(% of exports of goods, services and primary income) in Botswana in 1998 to that in 2001?
Provide a succinct answer. 1.35. What is the ratio of the Stocks(% of exports of goods, services and primary income) in Gabon in 1998 to that in 2001?
Ensure brevity in your answer.  1.66. What is the ratio of the Stocks(% of exports of goods, services and primary income) in Kazakhstan in 1998 to that in 2001?
Offer a terse response. 0.6. What is the ratio of the Stocks(% of exports of goods, services and primary income) in Botswana in 1998 to that in 2002?
Provide a short and direct response. 1.14. What is the ratio of the Stocks(% of exports of goods, services and primary income) of Gabon in 1998 to that in 2002?
Your answer should be very brief. 1.54. What is the ratio of the Stocks(% of exports of goods, services and primary income) in Kazakhstan in 1998 to that in 2002?
Your answer should be compact. 0.57. What is the ratio of the Stocks(% of exports of goods, services and primary income) of Botswana in 1999 to that in 2000?
Offer a very short reply. 1.1. What is the ratio of the Stocks(% of exports of goods, services and primary income) in Gabon in 1999 to that in 2000?
Your response must be concise. 1.26. What is the ratio of the Stocks(% of exports of goods, services and primary income) of Kazakhstan in 1999 to that in 2000?
Offer a terse response. 0.76. What is the ratio of the Stocks(% of exports of goods, services and primary income) in Botswana in 1999 to that in 2001?
Keep it short and to the point. 1.11. What is the ratio of the Stocks(% of exports of goods, services and primary income) of Gabon in 1999 to that in 2001?
Offer a terse response. 1.14. What is the ratio of the Stocks(% of exports of goods, services and primary income) in Kazakhstan in 1999 to that in 2001?
Provide a short and direct response. 0.64. What is the ratio of the Stocks(% of exports of goods, services and primary income) in Botswana in 1999 to that in 2002?
Provide a short and direct response. 0.94. What is the ratio of the Stocks(% of exports of goods, services and primary income) of Gabon in 1999 to that in 2002?
Your response must be concise. 1.06. What is the ratio of the Stocks(% of exports of goods, services and primary income) in Kazakhstan in 1999 to that in 2002?
Your response must be concise. 0.6. What is the ratio of the Stocks(% of exports of goods, services and primary income) of Botswana in 2000 to that in 2001?
Ensure brevity in your answer.  1.01. What is the ratio of the Stocks(% of exports of goods, services and primary income) in Gabon in 2000 to that in 2001?
Ensure brevity in your answer.  0.9. What is the ratio of the Stocks(% of exports of goods, services and primary income) in Kazakhstan in 2000 to that in 2001?
Ensure brevity in your answer.  0.83. What is the ratio of the Stocks(% of exports of goods, services and primary income) in Botswana in 2000 to that in 2002?
Make the answer very short. 0.85. What is the ratio of the Stocks(% of exports of goods, services and primary income) of Gabon in 2000 to that in 2002?
Provide a short and direct response. 0.84. What is the ratio of the Stocks(% of exports of goods, services and primary income) in Kazakhstan in 2000 to that in 2002?
Your answer should be very brief. 0.79. What is the ratio of the Stocks(% of exports of goods, services and primary income) of Botswana in 2001 to that in 2002?
Ensure brevity in your answer.  0.84. What is the ratio of the Stocks(% of exports of goods, services and primary income) in Gabon in 2001 to that in 2002?
Ensure brevity in your answer.  0.93. What is the ratio of the Stocks(% of exports of goods, services and primary income) of Kazakhstan in 2001 to that in 2002?
Keep it short and to the point. 0.94. What is the difference between the highest and the second highest Stocks(% of exports of goods, services and primary income) in Botswana?
Ensure brevity in your answer.  2.96. What is the difference between the highest and the second highest Stocks(% of exports of goods, services and primary income) in Gabon?
Offer a very short reply. 56.36. What is the difference between the highest and the second highest Stocks(% of exports of goods, services and primary income) of Kazakhstan?
Provide a short and direct response. 8.91. What is the difference between the highest and the lowest Stocks(% of exports of goods, services and primary income) of Botswana?
Offer a very short reply. 11.25. What is the difference between the highest and the lowest Stocks(% of exports of goods, services and primary income) in Gabon?
Give a very brief answer. 92.18. What is the difference between the highest and the lowest Stocks(% of exports of goods, services and primary income) in Kazakhstan?
Your answer should be compact. 114.62. 